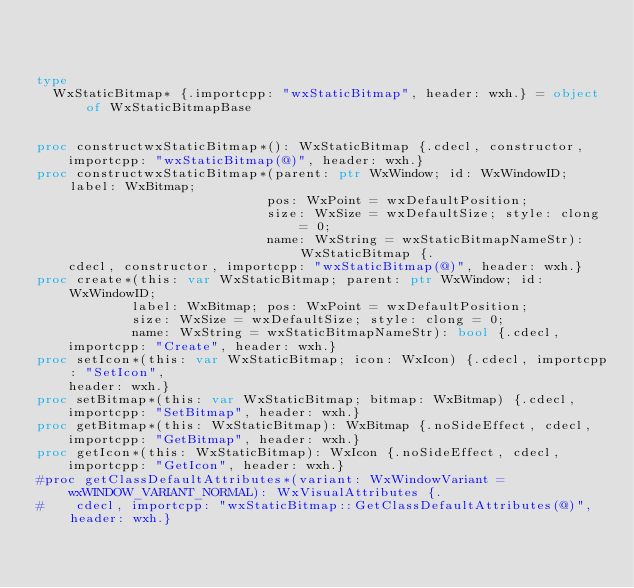<code> <loc_0><loc_0><loc_500><loc_500><_Nim_>


type
  WxStaticBitmap* {.importcpp: "wxStaticBitmap", header: wxh.} = object of WxStaticBitmapBase
  

proc constructwxStaticBitmap*(): WxStaticBitmap {.cdecl, constructor,
    importcpp: "wxStaticBitmap(@)", header: wxh.}
proc constructwxStaticBitmap*(parent: ptr WxWindow; id: WxWindowID; label: WxBitmap;
                             pos: WxPoint = wxDefaultPosition;
                             size: WxSize = wxDefaultSize; style: clong = 0;
                             name: WxString = wxStaticBitmapNameStr): WxStaticBitmap {.
    cdecl, constructor, importcpp: "wxStaticBitmap(@)", header: wxh.}
proc create*(this: var WxStaticBitmap; parent: ptr WxWindow; id: WxWindowID;
            label: WxBitmap; pos: WxPoint = wxDefaultPosition;
            size: WxSize = wxDefaultSize; style: clong = 0;
            name: WxString = wxStaticBitmapNameStr): bool {.cdecl,
    importcpp: "Create", header: wxh.}
proc setIcon*(this: var WxStaticBitmap; icon: WxIcon) {.cdecl, importcpp: "SetIcon",
    header: wxh.}
proc setBitmap*(this: var WxStaticBitmap; bitmap: WxBitmap) {.cdecl,
    importcpp: "SetBitmap", header: wxh.}
proc getBitmap*(this: WxStaticBitmap): WxBitmap {.noSideEffect, cdecl,
    importcpp: "GetBitmap", header: wxh.}
proc getIcon*(this: WxStaticBitmap): WxIcon {.noSideEffect, cdecl,
    importcpp: "GetIcon", header: wxh.}
#proc getClassDefaultAttributes*(variant: WxWindowVariant = wxWINDOW_VARIANT_NORMAL): WxVisualAttributes {.
#    cdecl, importcpp: "wxStaticBitmap::GetClassDefaultAttributes(@)", header: wxh.}</code> 